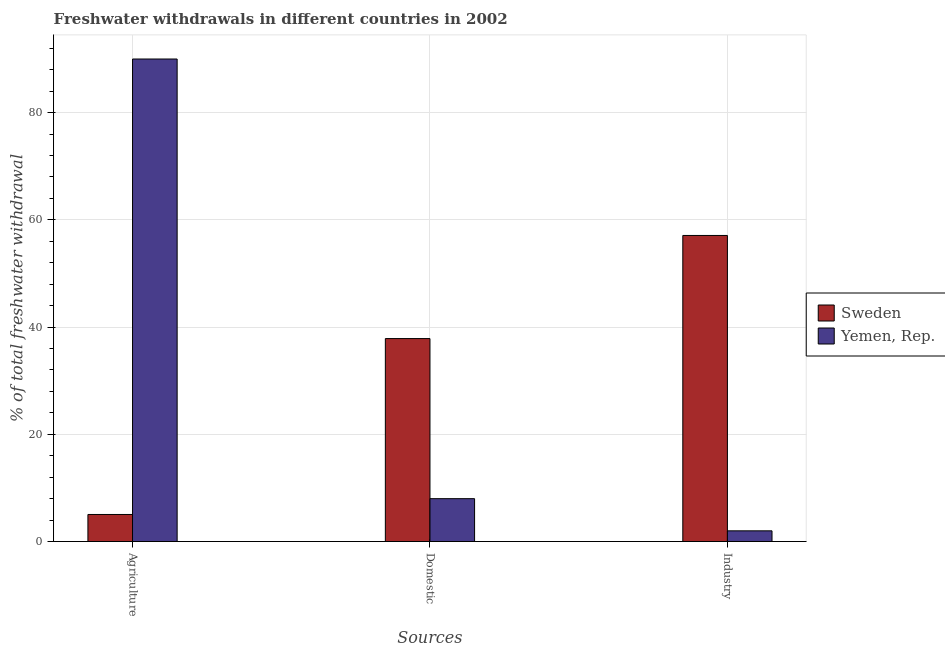How many bars are there on the 1st tick from the left?
Your answer should be compact. 2. How many bars are there on the 1st tick from the right?
Give a very brief answer. 2. What is the label of the 3rd group of bars from the left?
Keep it short and to the point. Industry. Across all countries, what is the maximum percentage of freshwater withdrawal for domestic purposes?
Provide a succinct answer. 37.86. In which country was the percentage of freshwater withdrawal for domestic purposes maximum?
Your answer should be very brief. Sweden. What is the total percentage of freshwater withdrawal for agriculture in the graph?
Offer a terse response. 95.05. What is the difference between the percentage of freshwater withdrawal for agriculture in Sweden and that in Yemen, Rep.?
Keep it short and to the point. -84.95. What is the difference between the percentage of freshwater withdrawal for agriculture in Sweden and the percentage of freshwater withdrawal for domestic purposes in Yemen, Rep.?
Your answer should be compact. -2.95. What is the average percentage of freshwater withdrawal for agriculture per country?
Provide a short and direct response. 47.53. What is the difference between the percentage of freshwater withdrawal for industry and percentage of freshwater withdrawal for agriculture in Sweden?
Your answer should be compact. 52.04. What is the ratio of the percentage of freshwater withdrawal for domestic purposes in Sweden to that in Yemen, Rep.?
Provide a succinct answer. 4.73. What is the difference between the highest and the second highest percentage of freshwater withdrawal for domestic purposes?
Offer a very short reply. 29.86. What is the difference between the highest and the lowest percentage of freshwater withdrawal for industry?
Ensure brevity in your answer.  55.09. In how many countries, is the percentage of freshwater withdrawal for domestic purposes greater than the average percentage of freshwater withdrawal for domestic purposes taken over all countries?
Offer a terse response. 1. What does the 2nd bar from the left in Agriculture represents?
Give a very brief answer. Yemen, Rep. What does the 1st bar from the right in Agriculture represents?
Provide a short and direct response. Yemen, Rep. Is it the case that in every country, the sum of the percentage of freshwater withdrawal for agriculture and percentage of freshwater withdrawal for domestic purposes is greater than the percentage of freshwater withdrawal for industry?
Offer a terse response. No. How many bars are there?
Your answer should be compact. 6. How many countries are there in the graph?
Your answer should be very brief. 2. Where does the legend appear in the graph?
Keep it short and to the point. Center right. What is the title of the graph?
Provide a succinct answer. Freshwater withdrawals in different countries in 2002. What is the label or title of the X-axis?
Give a very brief answer. Sources. What is the label or title of the Y-axis?
Offer a terse response. % of total freshwater withdrawal. What is the % of total freshwater withdrawal in Sweden in Agriculture?
Provide a succinct answer. 5.05. What is the % of total freshwater withdrawal in Sweden in Domestic?
Provide a succinct answer. 37.86. What is the % of total freshwater withdrawal in Yemen, Rep. in Domestic?
Provide a short and direct response. 8. What is the % of total freshwater withdrawal of Sweden in Industry?
Your answer should be compact. 57.09. Across all Sources, what is the maximum % of total freshwater withdrawal in Sweden?
Provide a succinct answer. 57.09. Across all Sources, what is the minimum % of total freshwater withdrawal of Sweden?
Your response must be concise. 5.05. What is the total % of total freshwater withdrawal in Sweden in the graph?
Provide a succinct answer. 100. What is the difference between the % of total freshwater withdrawal of Sweden in Agriculture and that in Domestic?
Make the answer very short. -32.81. What is the difference between the % of total freshwater withdrawal of Sweden in Agriculture and that in Industry?
Offer a very short reply. -52.04. What is the difference between the % of total freshwater withdrawal in Sweden in Domestic and that in Industry?
Provide a short and direct response. -19.23. What is the difference between the % of total freshwater withdrawal in Sweden in Agriculture and the % of total freshwater withdrawal in Yemen, Rep. in Domestic?
Give a very brief answer. -2.95. What is the difference between the % of total freshwater withdrawal of Sweden in Agriculture and the % of total freshwater withdrawal of Yemen, Rep. in Industry?
Your answer should be compact. 3.05. What is the difference between the % of total freshwater withdrawal in Sweden in Domestic and the % of total freshwater withdrawal in Yemen, Rep. in Industry?
Ensure brevity in your answer.  35.86. What is the average % of total freshwater withdrawal in Sweden per Sources?
Your answer should be very brief. 33.33. What is the average % of total freshwater withdrawal of Yemen, Rep. per Sources?
Your response must be concise. 33.33. What is the difference between the % of total freshwater withdrawal of Sweden and % of total freshwater withdrawal of Yemen, Rep. in Agriculture?
Your response must be concise. -84.95. What is the difference between the % of total freshwater withdrawal in Sweden and % of total freshwater withdrawal in Yemen, Rep. in Domestic?
Give a very brief answer. 29.86. What is the difference between the % of total freshwater withdrawal of Sweden and % of total freshwater withdrawal of Yemen, Rep. in Industry?
Your answer should be compact. 55.09. What is the ratio of the % of total freshwater withdrawal of Sweden in Agriculture to that in Domestic?
Make the answer very short. 0.13. What is the ratio of the % of total freshwater withdrawal in Yemen, Rep. in Agriculture to that in Domestic?
Your response must be concise. 11.25. What is the ratio of the % of total freshwater withdrawal in Sweden in Agriculture to that in Industry?
Give a very brief answer. 0.09. What is the ratio of the % of total freshwater withdrawal in Yemen, Rep. in Agriculture to that in Industry?
Make the answer very short. 45. What is the ratio of the % of total freshwater withdrawal of Sweden in Domestic to that in Industry?
Give a very brief answer. 0.66. What is the difference between the highest and the second highest % of total freshwater withdrawal in Sweden?
Ensure brevity in your answer.  19.23. What is the difference between the highest and the second highest % of total freshwater withdrawal in Yemen, Rep.?
Provide a short and direct response. 82. What is the difference between the highest and the lowest % of total freshwater withdrawal in Sweden?
Give a very brief answer. 52.04. 